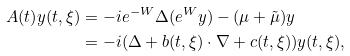Convert formula to latex. <formula><loc_0><loc_0><loc_500><loc_500>A ( t ) y ( t , \xi ) & = - i e ^ { - W } \Delta ( e ^ { W } y ) - ( \mu + \tilde { \mu } ) y \\ & = - i ( \Delta + b ( t , \xi ) \cdot \nabla + c ( t , \xi ) ) y ( t , \xi ) ,</formula> 